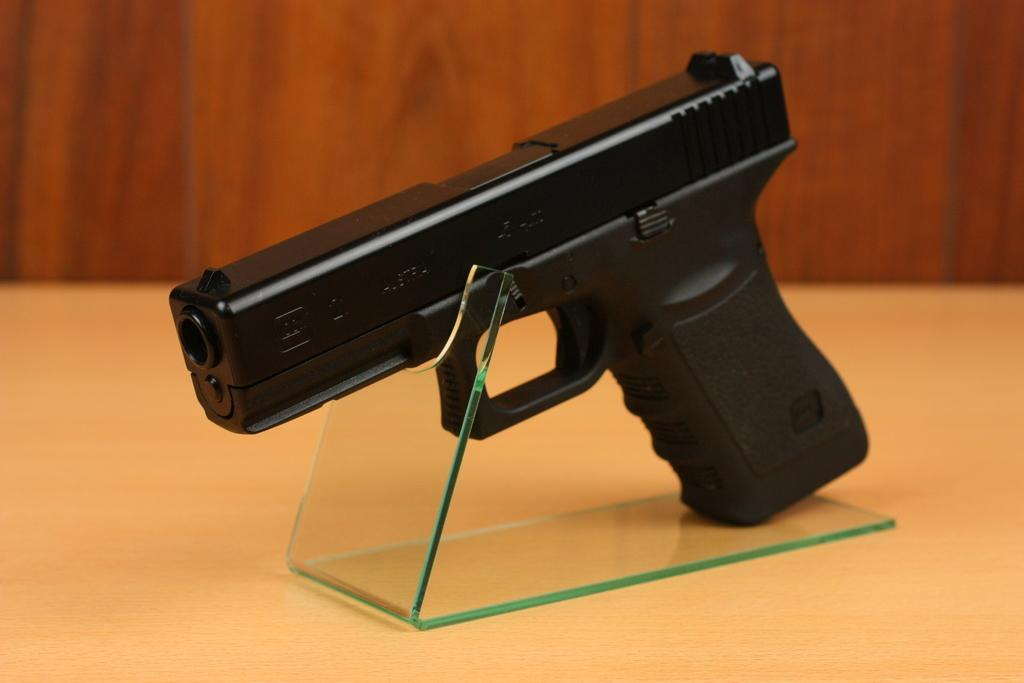What object is the main subject of the image? There is a revolver in the image. How is the revolver positioned in the image? The revolver is placed on a stand. What can be seen in the background of the image? There is a wall in the background of the image. What type of ball is being used in the image? There is no ball present in the image. --- Facts: 1. There is a person in the image. 2. The person is wearing a hat. 3. The person is holding a book. 4. The background of the image is a library. Absurd Topics: piano Who or what is the main subject of the image? The main subject of the image is a person. What is the person in the image wearing? The person in the image is wearing a hat. What is the person in the image holding? The person in the image is holding a book. Where is the person in the image located? The person in the image is located in a library. Reasoning: Let's think step by step in order to produce the conversation. We start by identifying the main subject of the image, which is a person. Next, we describe the clothing or accessories the person is wearing, which is a hat. Then, we observe the actions of the person in the image, noting that they are holding a book. Finally, we describe the background of the image, which is a library. Absurd Question/Answer: What type of piano can be seen in the image? There is no piano present in the image. --- Facts: 1. There is a dog in the image. 2. The dog is sitting on a chair. 3. The dog is wearing a bow tie. 4. The background of the image is a park. Absurd Topics: cat Conversation: What type of animal is the main subject of the image? The main subject of the image is a dog. What is the dog in the image doing? The dog in the image is sitting on a chair. What is the dog in the image wearing? The dog in the image is wearing a bow tie. Where is the dog in the image located? The dog in the image is located in a park. Reasoning: Let's think step by step in order to produce the conversation. We start by identifying the main subject of the image, which is a dog. Next, we describe the positioning of the dog in the image, noting that they are sitting on a chair. Then, we observe the actions of the dog in the image, noting that they are wearing a bow tie. Finally, we describe the background of the image, which is a park. Absurd Question/Answer: What type of cat can be seen playing with the dog in the image? There is no cat present in the image. --- Facts: 1. There is a person in the image. 2. 